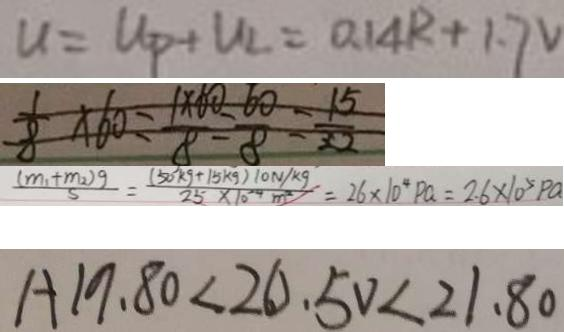Convert formula to latex. <formula><loc_0><loc_0><loc_500><loc_500>u = U _ { p } + U _ { 2 } = 0 . 1 4 R + 1 . 7 V 
 \frac { 1 } { 8 } \times 6 0 = \frac { 1 \times 6 0 } { 8 } = \frac { 6 0 } { 8 } = \frac { 1 5 } { 2 2 } 
 \frac { ( m _ { 1 } + m _ { 2 } ) g } { 5 } = \frac { ( 5 0 k g + 1 5 k g ) 1 0 N / k g } { 2 5 \times 1 0 ^ { 2 4 } m ^ { 2 } } = 2 6 \times 1 0 ^ { 4 } P a = 2 . 6 \times 1 0 ^ { 5 } P a 
 A 1 9 . 8 0 < 2 0 . 5 0 < 2 1 . 8 0</formula> 